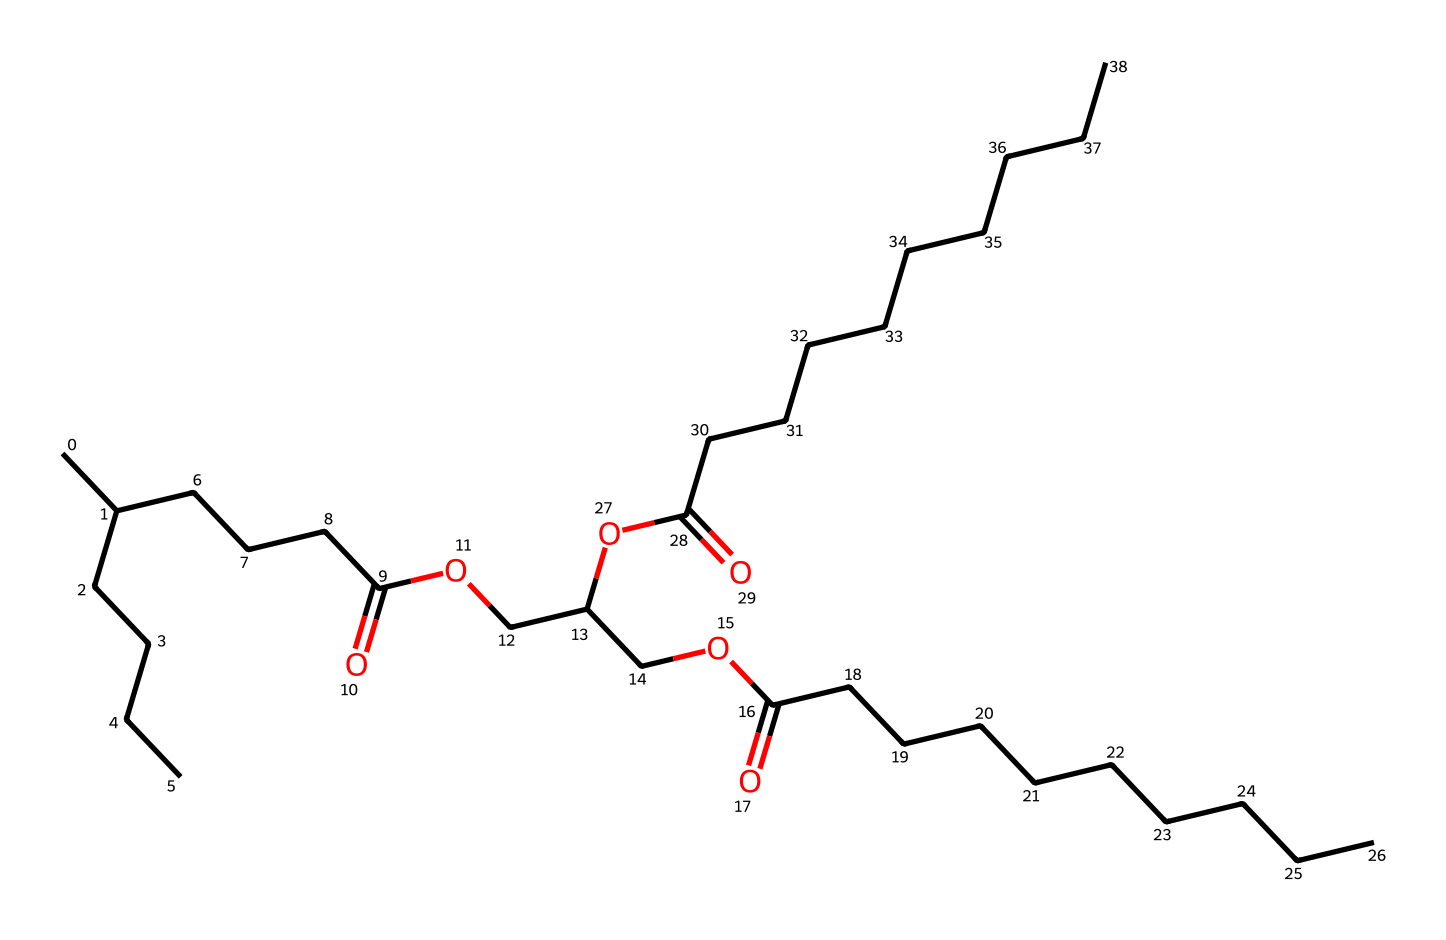What functional groups are present in this chemical? The chemical structure contains a carboxylic acid group (-COOH) from the ester linkage and the fatty acid chains. Additionally, there are ether linkages (-O-) present between the glycerol backbone and the fatty acid chains.
Answer: carboxylic acid and ether How many carbon atoms are in the triglyceride molecule? By analyzing the SMILES representation, we count the carbon atoms represented within the structure. The arrangement suggests a total of 36 carbon atoms throughout the entire structure.
Answer: 36 What type of lipid is represented by this chemical structure? The presence of a glycerol backbone and three fatty acid chains indicates that this structure represents a triglyceride, which is a common type of lipid.
Answer: triglyceride How many ester linkages are present in this triglyceride? A triglyceride has three ester linkages formed between the glycerol backbone and each of the fatty acids. Each linkage is indicated by the connections seen in the SMILES structure where the -O- components are located.
Answer: 3 What is the primary role of triglycerides in soil stabilization techniques? Triglycerides serve as bio-based binders or emulsifiers and can enhance soil cohesion and stability due to their hydrophobic properties and ability to form long-lasting structures in soil treatments.
Answer: binders What is the degree of saturation observed in the fatty acid chains? By examining the structure, the fatty acid chains are primarily saturated, indicated by the presence of single bonds in the carbon chains along with the final carbons in the -COOH groups, though one may check for unsaturation in the specific chains.
Answer: saturated 